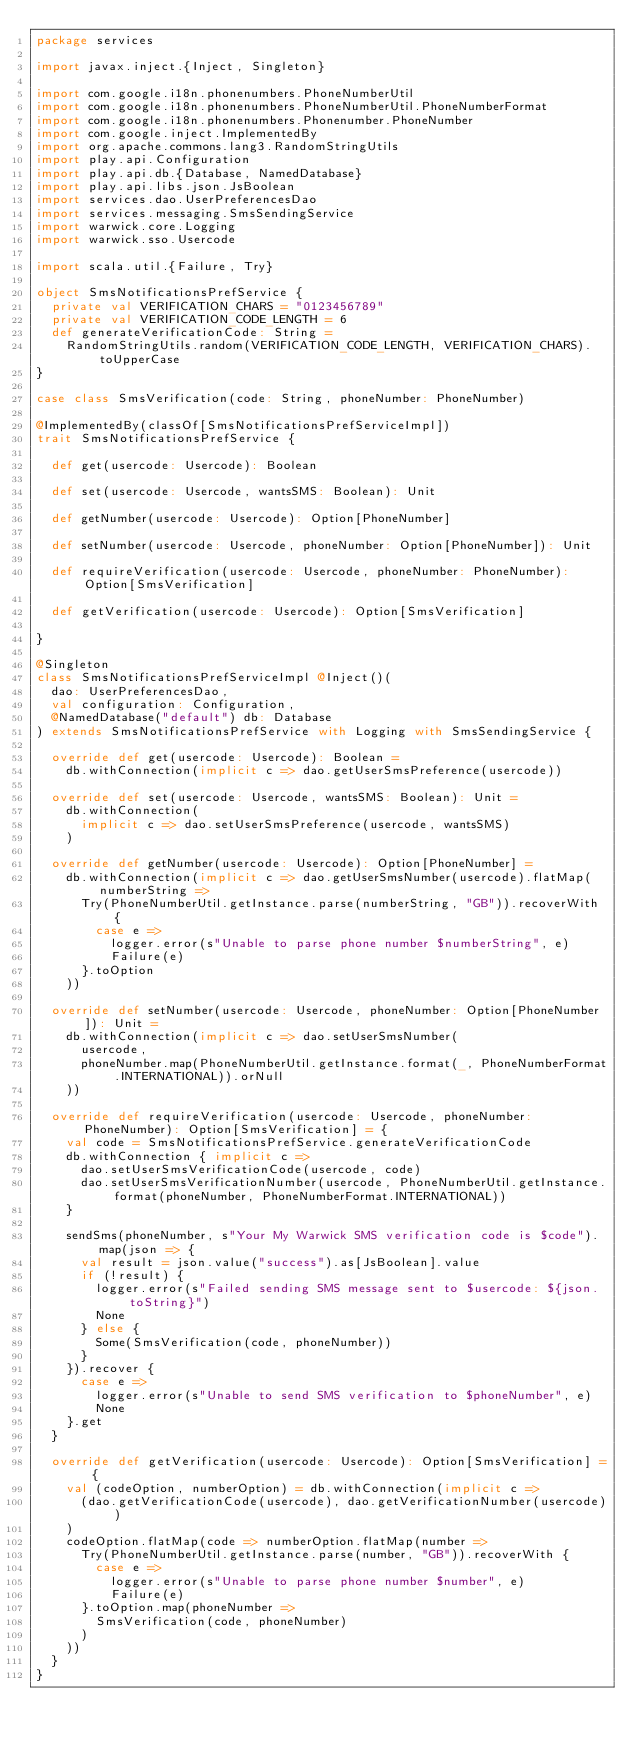<code> <loc_0><loc_0><loc_500><loc_500><_Scala_>package services

import javax.inject.{Inject, Singleton}

import com.google.i18n.phonenumbers.PhoneNumberUtil
import com.google.i18n.phonenumbers.PhoneNumberUtil.PhoneNumberFormat
import com.google.i18n.phonenumbers.Phonenumber.PhoneNumber
import com.google.inject.ImplementedBy
import org.apache.commons.lang3.RandomStringUtils
import play.api.Configuration
import play.api.db.{Database, NamedDatabase}
import play.api.libs.json.JsBoolean
import services.dao.UserPreferencesDao
import services.messaging.SmsSendingService
import warwick.core.Logging
import warwick.sso.Usercode

import scala.util.{Failure, Try}

object SmsNotificationsPrefService {
  private val VERIFICATION_CHARS = "0123456789"
  private val VERIFICATION_CODE_LENGTH = 6
  def generateVerificationCode: String =
    RandomStringUtils.random(VERIFICATION_CODE_LENGTH, VERIFICATION_CHARS).toUpperCase
}

case class SmsVerification(code: String, phoneNumber: PhoneNumber)

@ImplementedBy(classOf[SmsNotificationsPrefServiceImpl])
trait SmsNotificationsPrefService {

  def get(usercode: Usercode): Boolean

  def set(usercode: Usercode, wantsSMS: Boolean): Unit

  def getNumber(usercode: Usercode): Option[PhoneNumber]

  def setNumber(usercode: Usercode, phoneNumber: Option[PhoneNumber]): Unit

  def requireVerification(usercode: Usercode, phoneNumber: PhoneNumber): Option[SmsVerification]

  def getVerification(usercode: Usercode): Option[SmsVerification]

}

@Singleton
class SmsNotificationsPrefServiceImpl @Inject()(
  dao: UserPreferencesDao,
  val configuration: Configuration,
  @NamedDatabase("default") db: Database
) extends SmsNotificationsPrefService with Logging with SmsSendingService {

  override def get(usercode: Usercode): Boolean =
    db.withConnection(implicit c => dao.getUserSmsPreference(usercode))

  override def set(usercode: Usercode, wantsSMS: Boolean): Unit =
    db.withConnection(
      implicit c => dao.setUserSmsPreference(usercode, wantsSMS)
    )

  override def getNumber(usercode: Usercode): Option[PhoneNumber] =
    db.withConnection(implicit c => dao.getUserSmsNumber(usercode).flatMap(numberString =>
      Try(PhoneNumberUtil.getInstance.parse(numberString, "GB")).recoverWith {
        case e =>
          logger.error(s"Unable to parse phone number $numberString", e)
          Failure(e)
      }.toOption
    ))

  override def setNumber(usercode: Usercode, phoneNumber: Option[PhoneNumber]): Unit =
    db.withConnection(implicit c => dao.setUserSmsNumber(
      usercode,
      phoneNumber.map(PhoneNumberUtil.getInstance.format(_, PhoneNumberFormat.INTERNATIONAL)).orNull
    ))

  override def requireVerification(usercode: Usercode, phoneNumber: PhoneNumber): Option[SmsVerification] = {
    val code = SmsNotificationsPrefService.generateVerificationCode
    db.withConnection { implicit c =>
      dao.setUserSmsVerificationCode(usercode, code)
      dao.setUserSmsVerificationNumber(usercode, PhoneNumberUtil.getInstance.format(phoneNumber, PhoneNumberFormat.INTERNATIONAL))
    }

    sendSms(phoneNumber, s"Your My Warwick SMS verification code is $code").map(json => {
      val result = json.value("success").as[JsBoolean].value
      if (!result) {
        logger.error(s"Failed sending SMS message sent to $usercode: ${json.toString}")
        None
      } else {
        Some(SmsVerification(code, phoneNumber))
      }
    }).recover {
      case e =>
        logger.error(s"Unable to send SMS verification to $phoneNumber", e)
        None
    }.get
  }

  override def getVerification(usercode: Usercode): Option[SmsVerification] = {
    val (codeOption, numberOption) = db.withConnection(implicit c =>
      (dao.getVerificationCode(usercode), dao.getVerificationNumber(usercode))
    )
    codeOption.flatMap(code => numberOption.flatMap(number =>
      Try(PhoneNumberUtil.getInstance.parse(number, "GB")).recoverWith {
        case e =>
          logger.error(s"Unable to parse phone number $number", e)
          Failure(e)
      }.toOption.map(phoneNumber =>
        SmsVerification(code, phoneNumber)
      )
    ))
  }
}
</code> 